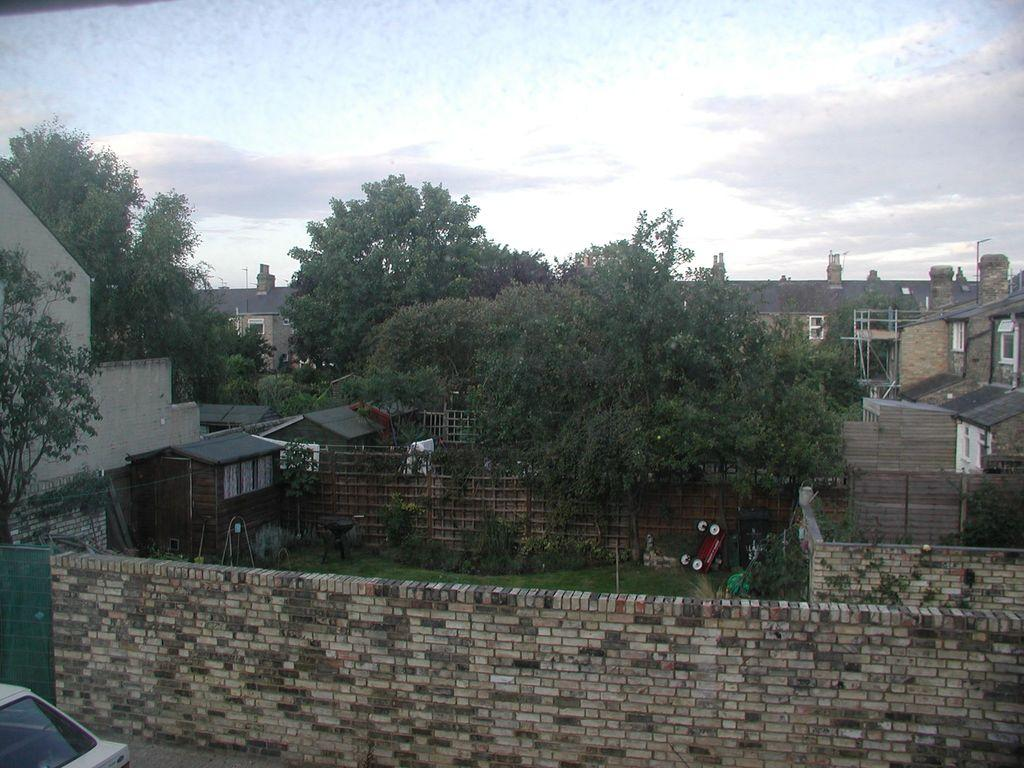What type of vegetation is in the middle of the image? There are green trees in the middle of the image. What structures can be seen in the image? There are houses in the image. What is visible at the top of the image? The sky is visible at the top of the image. How many boats are visible in the image? There are no boats present in the image. What type of curve can be seen on the trees in the image? There is no curve mentioned or visible on the trees in the image; they are simply described as green trees. 